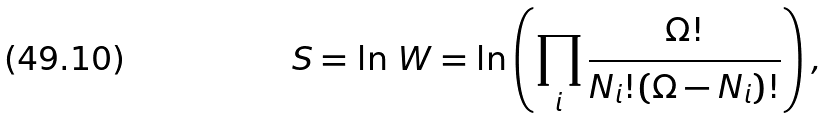<formula> <loc_0><loc_0><loc_500><loc_500>S = \ln \, W = \ln \left ( \prod _ { i } \frac { \Omega ! } { N _ { i } ! ( \Omega - N _ { i } ) ! } \right ) ,</formula> 